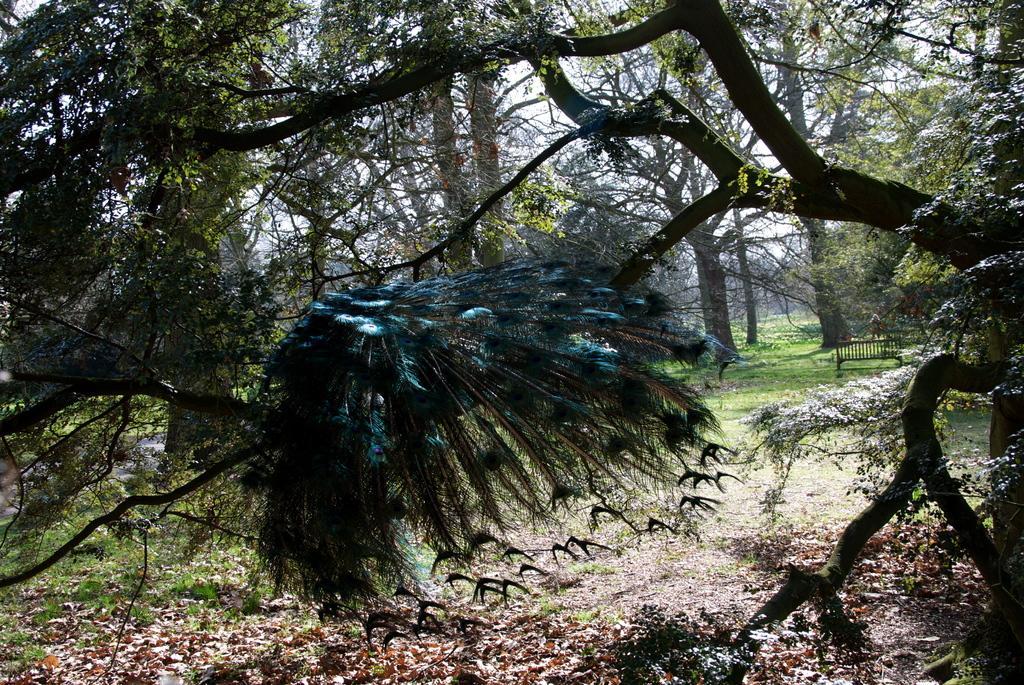Can you describe this image briefly? This is an outside view. In this image I can see many trees. In the middle of the image I can see some peacock feathers on a tree. On the right side, I can see a bench which is placed on the ground. At the bottom of the image there are many leaves and plants on the ground. 